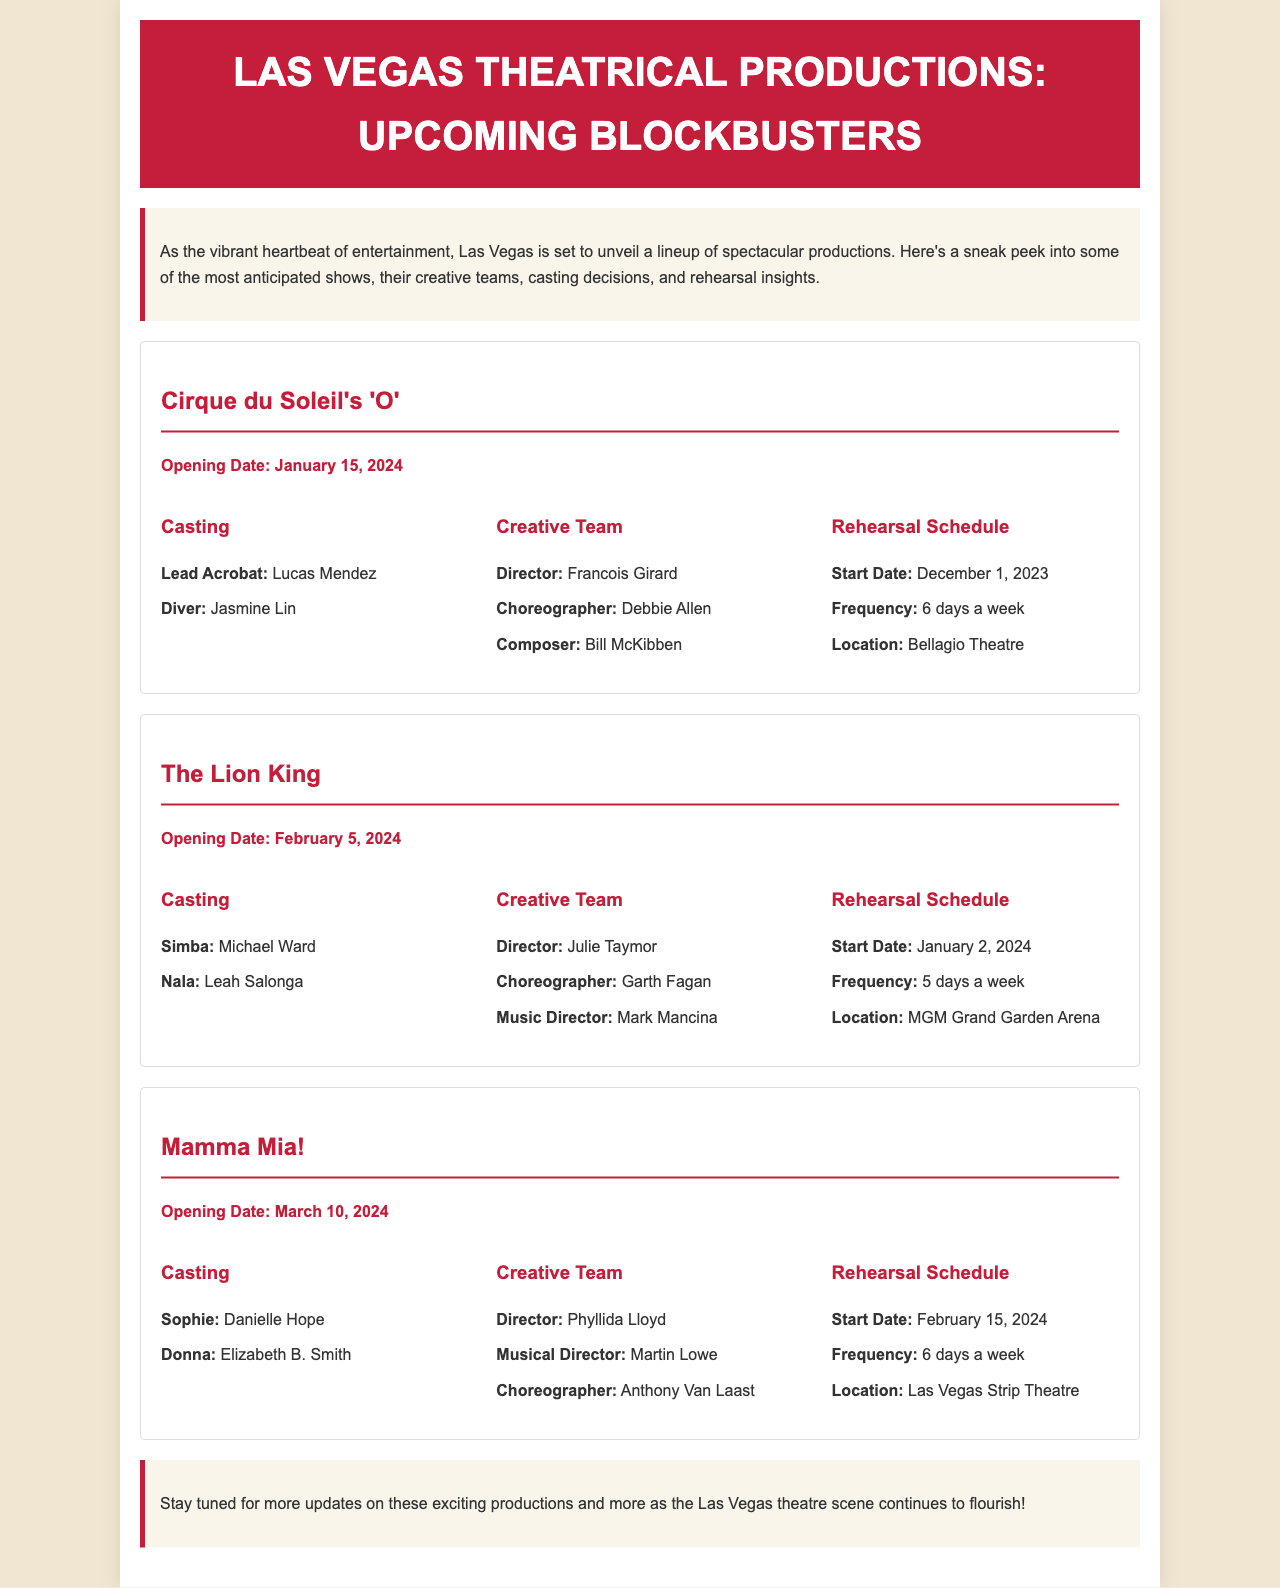What is the opening date for 'O'? The opening date for 'O' is explicitly stated in the document as January 15, 2024.
Answer: January 15, 2024 Who is the lead acrobat for 'O'? In the casting section for 'O', Lucas Mendez is named as the lead acrobat.
Answer: Lucas Mendez What is the rehearsal frequency for Mamma Mia!? The rehearsal schedule specifies that Mamma Mia! will rehearse 6 days a week.
Answer: 6 days a week Who is directing The Lion King? The creative team for The Lion King lists Julie Taymor as the director.
Answer: Julie Taymor What is the start date for The Lion King's rehearsals? The document indicates that rehearsals for The Lion King start on January 2, 2024.
Answer: January 2, 2024 Which location will Mamma Mia! rehearse at? According to the rehearsal schedule, Mamma Mia! is set to rehearse at the Las Vegas Strip Theatre.
Answer: Las Vegas Strip Theatre What is the role of Leah Salonga in The Lion King? The casting details for The Lion King mention Leah Salonga as Nala.
Answer: Nala How often will 'O' rehearse? The rehearsal details for 'O' specify a frequency of 6 days a week for rehearsals.
Answer: 6 days a week What is the composer for 'O'? In the creative team section for 'O', Bill McKibben is listed as the composer.
Answer: Bill McKibben 